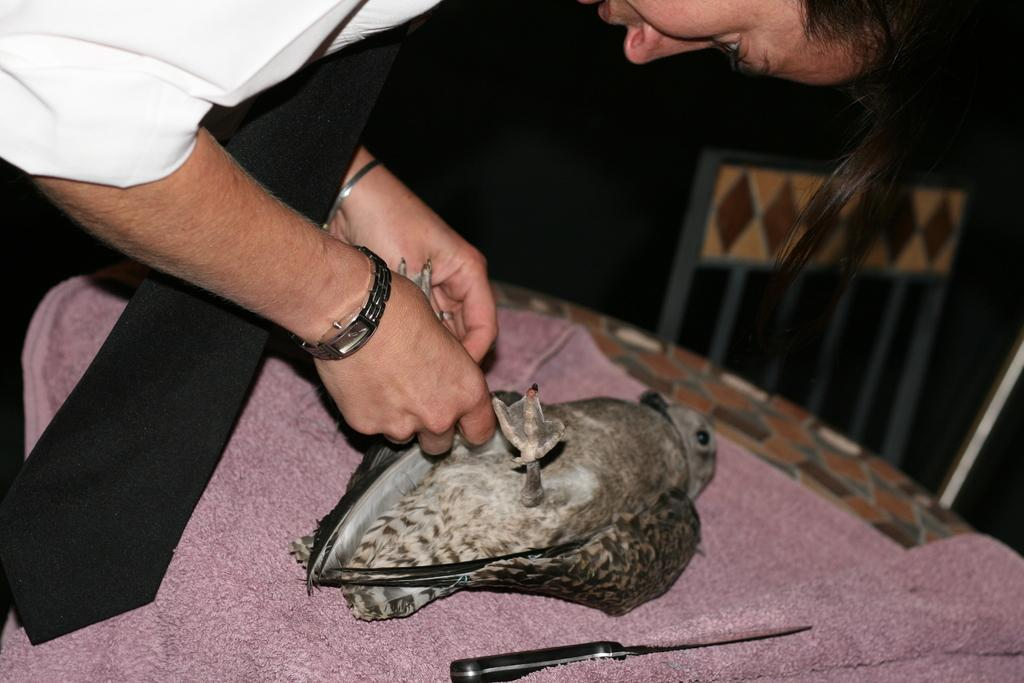Who is present in the image? There is a woman in the image. What is the woman holding? The woman is holding a bird. Where is the bird placed? The bird is placed on a table. What other object can be seen in the image? There is a knife visible in the image. What type of goldfish can be seen swimming in the vessel in the image? There is no vessel or goldfish present in the image. 